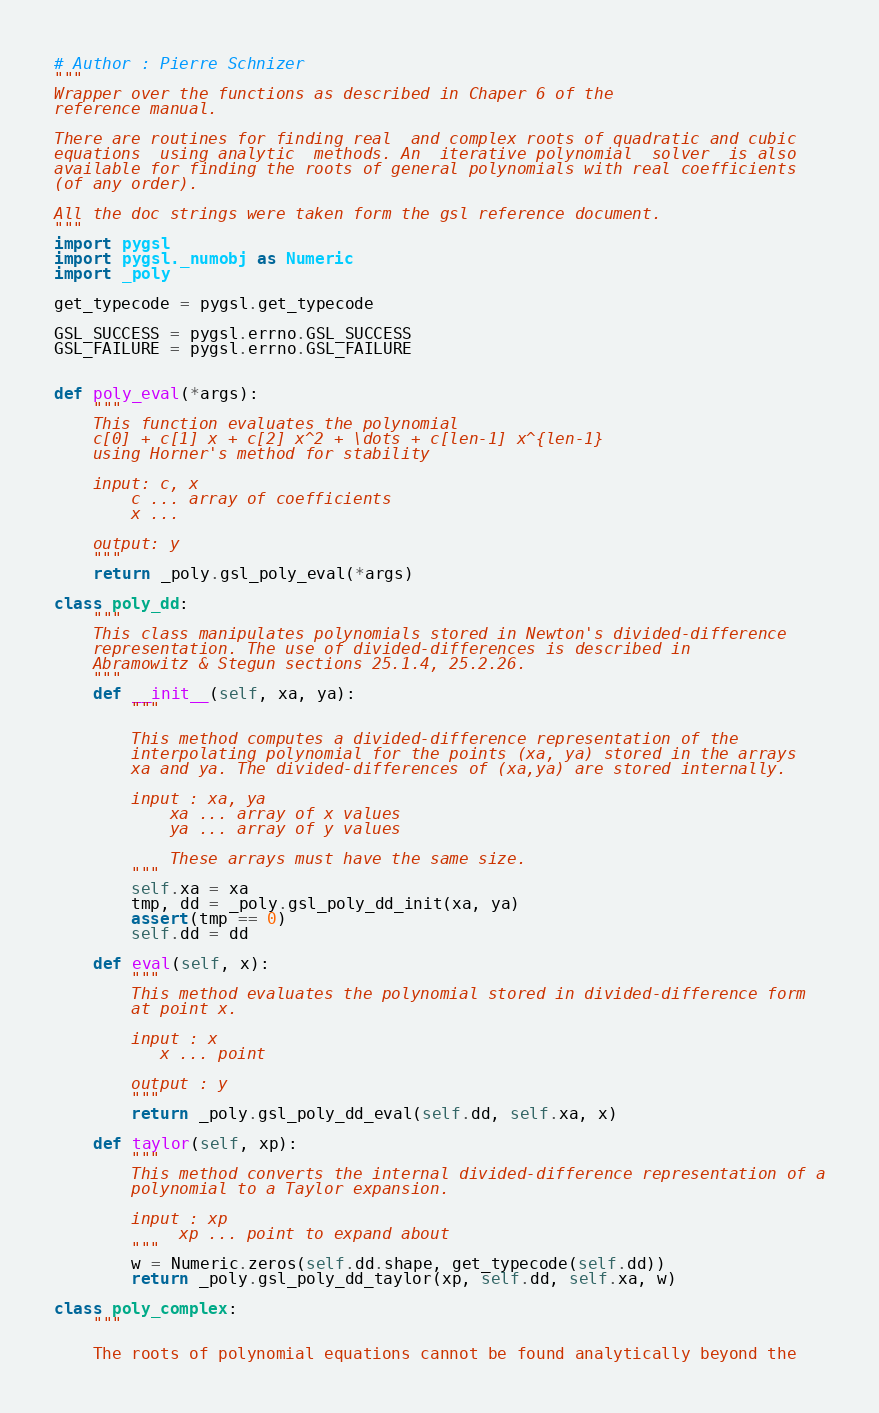Convert code to text. <code><loc_0><loc_0><loc_500><loc_500><_Python_># Author : Pierre Schnizer 
"""
Wrapper over the functions as described in Chaper 6 of the
reference manual.

There are routines for finding real  and complex roots of quadratic and cubic
equations  using analytic  methods. An  iterative polynomial  solver  is also
available for finding the roots of general polynomials with real coefficients
(of any order).

All the doc strings were taken form the gsl reference document.
"""
import pygsl
import pygsl._numobj as Numeric
import _poly

get_typecode = pygsl.get_typecode

GSL_SUCCESS = pygsl.errno.GSL_SUCCESS
GSL_FAILURE = pygsl.errno.GSL_FAILURE


def poly_eval(*args):
    """
    This function evaluates the polynomial
    c[0] + c[1] x + c[2] x^2 + \dots + c[len-1] x^{len-1}
    using Horner's method for stability

    input: c, x
        c ... array of coefficients
        x ... 
        
    output: y    
    """
    return _poly.gsl_poly_eval(*args)

class poly_dd:
    """
    This class manipulates polynomials stored in Newton's divided-difference
    representation. The use of divided-differences is described in
    Abramowitz & Stegun sections 25.1.4, 25.2.26. 
    """
    def __init__(self, xa, ya):
        """
        
        This method computes a divided-difference representation of the
        interpolating polynomial for the points (xa, ya) stored in the arrays
        xa and ya. The divided-differences of (xa,ya) are stored internally.

        input : xa, ya
            xa ... array of x values
            ya ... array of y values

            These arrays must have the same size.
        """
        self.xa = xa
        tmp, dd = _poly.gsl_poly_dd_init(xa, ya)
        assert(tmp == 0)
        self.dd = dd
        
    def eval(self, x):
        """
        This method evaluates the polynomial stored in divided-difference form
        at point x.

        input : x
           x ... point

        output : y   
        """        
        return _poly.gsl_poly_dd_eval(self.dd, self.xa, x)

    def taylor(self, xp):
        """
        This method converts the internal divided-difference representation of a
        polynomial to a Taylor expansion.

        input : xp
             xp ... point to expand about
        """
        w = Numeric.zeros(self.dd.shape, get_typecode(self.dd))
        return _poly.gsl_poly_dd_taylor(xp, self.dd, self.xa, w)
    
class poly_complex:
    """

    The roots of polynomial equations cannot be found analytically beyond the</code> 